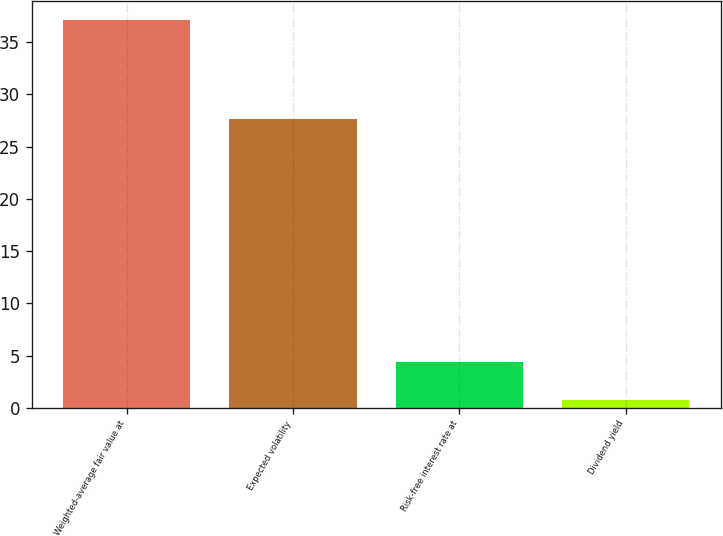Convert chart to OTSL. <chart><loc_0><loc_0><loc_500><loc_500><bar_chart><fcel>Weighted-average fair value at<fcel>Expected volatility<fcel>Risk-free interest rate at<fcel>Dividend yield<nl><fcel>37.12<fcel>27.6<fcel>4.34<fcel>0.7<nl></chart> 